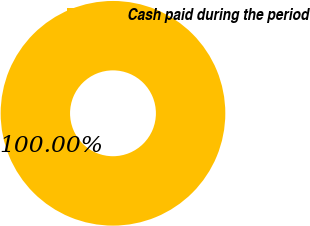Convert chart. <chart><loc_0><loc_0><loc_500><loc_500><pie_chart><fcel>Cash paid during the period<nl><fcel>100.0%<nl></chart> 